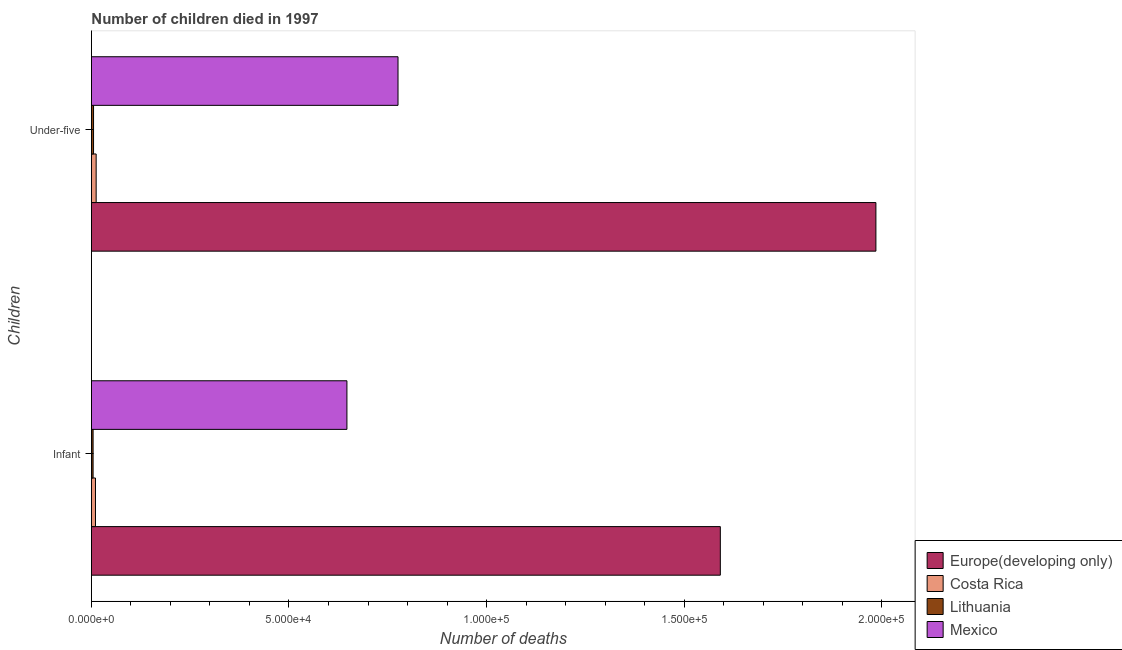How many different coloured bars are there?
Provide a succinct answer. 4. How many groups of bars are there?
Offer a terse response. 2. What is the label of the 2nd group of bars from the top?
Offer a terse response. Infant. What is the number of under-five deaths in Lithuania?
Ensure brevity in your answer.  538. Across all countries, what is the maximum number of infant deaths?
Give a very brief answer. 1.59e+05. Across all countries, what is the minimum number of infant deaths?
Your answer should be very brief. 422. In which country was the number of under-five deaths maximum?
Your answer should be compact. Europe(developing only). In which country was the number of under-five deaths minimum?
Ensure brevity in your answer.  Lithuania. What is the total number of infant deaths in the graph?
Your answer should be compact. 2.25e+05. What is the difference between the number of infant deaths in Mexico and that in Europe(developing only)?
Make the answer very short. -9.45e+04. What is the difference between the number of under-five deaths in Europe(developing only) and the number of infant deaths in Costa Rica?
Your response must be concise. 1.98e+05. What is the average number of infant deaths per country?
Give a very brief answer. 5.63e+04. What is the difference between the number of under-five deaths and number of infant deaths in Costa Rica?
Offer a very short reply. 172. In how many countries, is the number of under-five deaths greater than 90000 ?
Offer a terse response. 1. What is the ratio of the number of under-five deaths in Mexico to that in Costa Rica?
Offer a very short reply. 64.77. In how many countries, is the number of under-five deaths greater than the average number of under-five deaths taken over all countries?
Offer a terse response. 2. What does the 4th bar from the top in Infant represents?
Ensure brevity in your answer.  Europe(developing only). What does the 1st bar from the bottom in Infant represents?
Offer a very short reply. Europe(developing only). Are all the bars in the graph horizontal?
Your answer should be very brief. Yes. What is the difference between two consecutive major ticks on the X-axis?
Ensure brevity in your answer.  5.00e+04. Does the graph contain any zero values?
Give a very brief answer. No. Where does the legend appear in the graph?
Give a very brief answer. Bottom right. How many legend labels are there?
Offer a terse response. 4. What is the title of the graph?
Keep it short and to the point. Number of children died in 1997. Does "San Marino" appear as one of the legend labels in the graph?
Provide a succinct answer. No. What is the label or title of the X-axis?
Provide a short and direct response. Number of deaths. What is the label or title of the Y-axis?
Your answer should be very brief. Children. What is the Number of deaths of Europe(developing only) in Infant?
Your answer should be very brief. 1.59e+05. What is the Number of deaths of Costa Rica in Infant?
Offer a very short reply. 1026. What is the Number of deaths of Lithuania in Infant?
Offer a terse response. 422. What is the Number of deaths in Mexico in Infant?
Keep it short and to the point. 6.47e+04. What is the Number of deaths in Europe(developing only) in Under-five?
Make the answer very short. 1.99e+05. What is the Number of deaths of Costa Rica in Under-five?
Ensure brevity in your answer.  1198. What is the Number of deaths of Lithuania in Under-five?
Make the answer very short. 538. What is the Number of deaths in Mexico in Under-five?
Ensure brevity in your answer.  7.76e+04. Across all Children, what is the maximum Number of deaths in Europe(developing only)?
Ensure brevity in your answer.  1.99e+05. Across all Children, what is the maximum Number of deaths in Costa Rica?
Provide a short and direct response. 1198. Across all Children, what is the maximum Number of deaths in Lithuania?
Give a very brief answer. 538. Across all Children, what is the maximum Number of deaths of Mexico?
Your answer should be compact. 7.76e+04. Across all Children, what is the minimum Number of deaths in Europe(developing only)?
Offer a very short reply. 1.59e+05. Across all Children, what is the minimum Number of deaths in Costa Rica?
Ensure brevity in your answer.  1026. Across all Children, what is the minimum Number of deaths in Lithuania?
Your answer should be compact. 422. Across all Children, what is the minimum Number of deaths of Mexico?
Ensure brevity in your answer.  6.47e+04. What is the total Number of deaths in Europe(developing only) in the graph?
Offer a very short reply. 3.58e+05. What is the total Number of deaths in Costa Rica in the graph?
Provide a short and direct response. 2224. What is the total Number of deaths of Lithuania in the graph?
Give a very brief answer. 960. What is the total Number of deaths in Mexico in the graph?
Keep it short and to the point. 1.42e+05. What is the difference between the Number of deaths of Europe(developing only) in Infant and that in Under-five?
Provide a short and direct response. -3.94e+04. What is the difference between the Number of deaths in Costa Rica in Infant and that in Under-five?
Provide a short and direct response. -172. What is the difference between the Number of deaths in Lithuania in Infant and that in Under-five?
Ensure brevity in your answer.  -116. What is the difference between the Number of deaths in Mexico in Infant and that in Under-five?
Offer a terse response. -1.29e+04. What is the difference between the Number of deaths in Europe(developing only) in Infant and the Number of deaths in Costa Rica in Under-five?
Make the answer very short. 1.58e+05. What is the difference between the Number of deaths in Europe(developing only) in Infant and the Number of deaths in Lithuania in Under-five?
Provide a short and direct response. 1.59e+05. What is the difference between the Number of deaths of Europe(developing only) in Infant and the Number of deaths of Mexico in Under-five?
Offer a very short reply. 8.16e+04. What is the difference between the Number of deaths of Costa Rica in Infant and the Number of deaths of Lithuania in Under-five?
Keep it short and to the point. 488. What is the difference between the Number of deaths of Costa Rica in Infant and the Number of deaths of Mexico in Under-five?
Provide a succinct answer. -7.66e+04. What is the difference between the Number of deaths in Lithuania in Infant and the Number of deaths in Mexico in Under-five?
Keep it short and to the point. -7.72e+04. What is the average Number of deaths in Europe(developing only) per Children?
Offer a terse response. 1.79e+05. What is the average Number of deaths in Costa Rica per Children?
Your answer should be very brief. 1112. What is the average Number of deaths in Lithuania per Children?
Make the answer very short. 480. What is the average Number of deaths in Mexico per Children?
Give a very brief answer. 7.11e+04. What is the difference between the Number of deaths in Europe(developing only) and Number of deaths in Costa Rica in Infant?
Offer a terse response. 1.58e+05. What is the difference between the Number of deaths of Europe(developing only) and Number of deaths of Lithuania in Infant?
Keep it short and to the point. 1.59e+05. What is the difference between the Number of deaths in Europe(developing only) and Number of deaths in Mexico in Infant?
Give a very brief answer. 9.45e+04. What is the difference between the Number of deaths of Costa Rica and Number of deaths of Lithuania in Infant?
Your answer should be compact. 604. What is the difference between the Number of deaths in Costa Rica and Number of deaths in Mexico in Infant?
Make the answer very short. -6.36e+04. What is the difference between the Number of deaths in Lithuania and Number of deaths in Mexico in Infant?
Provide a succinct answer. -6.42e+04. What is the difference between the Number of deaths in Europe(developing only) and Number of deaths in Costa Rica in Under-five?
Offer a terse response. 1.97e+05. What is the difference between the Number of deaths in Europe(developing only) and Number of deaths in Lithuania in Under-five?
Offer a terse response. 1.98e+05. What is the difference between the Number of deaths in Europe(developing only) and Number of deaths in Mexico in Under-five?
Your answer should be compact. 1.21e+05. What is the difference between the Number of deaths in Costa Rica and Number of deaths in Lithuania in Under-five?
Ensure brevity in your answer.  660. What is the difference between the Number of deaths in Costa Rica and Number of deaths in Mexico in Under-five?
Provide a succinct answer. -7.64e+04. What is the difference between the Number of deaths of Lithuania and Number of deaths of Mexico in Under-five?
Make the answer very short. -7.71e+04. What is the ratio of the Number of deaths in Europe(developing only) in Infant to that in Under-five?
Offer a terse response. 0.8. What is the ratio of the Number of deaths in Costa Rica in Infant to that in Under-five?
Provide a succinct answer. 0.86. What is the ratio of the Number of deaths in Lithuania in Infant to that in Under-five?
Your answer should be very brief. 0.78. What is the difference between the highest and the second highest Number of deaths of Europe(developing only)?
Your answer should be compact. 3.94e+04. What is the difference between the highest and the second highest Number of deaths in Costa Rica?
Your answer should be compact. 172. What is the difference between the highest and the second highest Number of deaths in Lithuania?
Provide a short and direct response. 116. What is the difference between the highest and the second highest Number of deaths in Mexico?
Offer a very short reply. 1.29e+04. What is the difference between the highest and the lowest Number of deaths in Europe(developing only)?
Offer a very short reply. 3.94e+04. What is the difference between the highest and the lowest Number of deaths of Costa Rica?
Your answer should be very brief. 172. What is the difference between the highest and the lowest Number of deaths in Lithuania?
Offer a terse response. 116. What is the difference between the highest and the lowest Number of deaths in Mexico?
Offer a very short reply. 1.29e+04. 